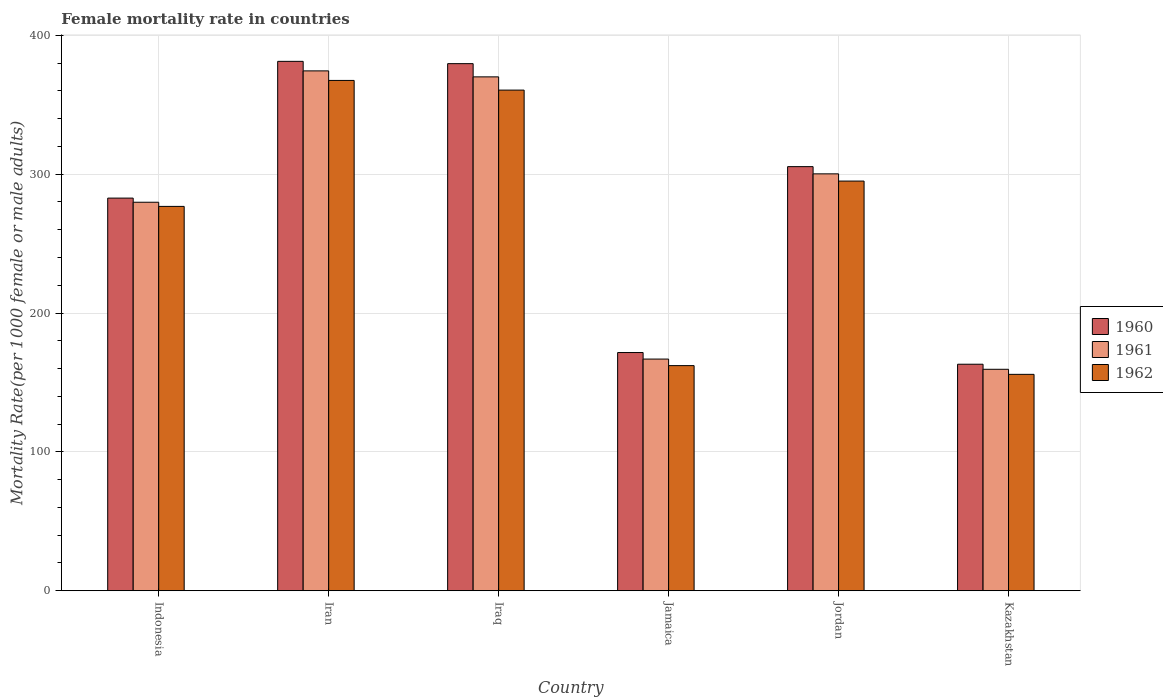How many groups of bars are there?
Ensure brevity in your answer.  6. Are the number of bars per tick equal to the number of legend labels?
Offer a very short reply. Yes. Are the number of bars on each tick of the X-axis equal?
Ensure brevity in your answer.  Yes. What is the label of the 4th group of bars from the left?
Keep it short and to the point. Jamaica. In how many cases, is the number of bars for a given country not equal to the number of legend labels?
Provide a short and direct response. 0. What is the female mortality rate in 1960 in Kazakhstan?
Provide a short and direct response. 163.12. Across all countries, what is the maximum female mortality rate in 1962?
Your answer should be compact. 367.5. Across all countries, what is the minimum female mortality rate in 1960?
Keep it short and to the point. 163.12. In which country was the female mortality rate in 1960 maximum?
Your response must be concise. Iran. In which country was the female mortality rate in 1961 minimum?
Make the answer very short. Kazakhstan. What is the total female mortality rate in 1960 in the graph?
Keep it short and to the point. 1683.64. What is the difference between the female mortality rate in 1960 in Indonesia and that in Kazakhstan?
Your answer should be very brief. 119.63. What is the difference between the female mortality rate in 1961 in Jordan and the female mortality rate in 1962 in Kazakhstan?
Give a very brief answer. 144.4. What is the average female mortality rate in 1961 per country?
Your answer should be compact. 275.12. What is the difference between the female mortality rate of/in 1962 and female mortality rate of/in 1960 in Indonesia?
Your response must be concise. -5.98. In how many countries, is the female mortality rate in 1962 greater than 200?
Your answer should be compact. 4. What is the ratio of the female mortality rate in 1961 in Iran to that in Iraq?
Keep it short and to the point. 1.01. Is the difference between the female mortality rate in 1962 in Indonesia and Jamaica greater than the difference between the female mortality rate in 1960 in Indonesia and Jamaica?
Provide a succinct answer. Yes. What is the difference between the highest and the second highest female mortality rate in 1962?
Offer a terse response. 65.51. What is the difference between the highest and the lowest female mortality rate in 1961?
Make the answer very short. 214.9. Is the sum of the female mortality rate in 1962 in Indonesia and Jordan greater than the maximum female mortality rate in 1960 across all countries?
Your answer should be very brief. Yes. What does the 1st bar from the right in Kazakhstan represents?
Your answer should be very brief. 1962. Are the values on the major ticks of Y-axis written in scientific E-notation?
Offer a terse response. No. Does the graph contain grids?
Your response must be concise. Yes. Where does the legend appear in the graph?
Your response must be concise. Center right. What is the title of the graph?
Offer a very short reply. Female mortality rate in countries. Does "1972" appear as one of the legend labels in the graph?
Your answer should be very brief. No. What is the label or title of the X-axis?
Give a very brief answer. Country. What is the label or title of the Y-axis?
Provide a short and direct response. Mortality Rate(per 1000 female or male adults). What is the Mortality Rate(per 1000 female or male adults) in 1960 in Indonesia?
Provide a short and direct response. 282.75. What is the Mortality Rate(per 1000 female or male adults) in 1961 in Indonesia?
Ensure brevity in your answer.  279.76. What is the Mortality Rate(per 1000 female or male adults) of 1962 in Indonesia?
Offer a terse response. 276.78. What is the Mortality Rate(per 1000 female or male adults) in 1960 in Iran?
Ensure brevity in your answer.  381.24. What is the Mortality Rate(per 1000 female or male adults) of 1961 in Iran?
Your response must be concise. 374.37. What is the Mortality Rate(per 1000 female or male adults) of 1962 in Iran?
Provide a succinct answer. 367.5. What is the Mortality Rate(per 1000 female or male adults) of 1960 in Iraq?
Give a very brief answer. 379.58. What is the Mortality Rate(per 1000 female or male adults) in 1961 in Iraq?
Your response must be concise. 370.06. What is the Mortality Rate(per 1000 female or male adults) in 1962 in Iraq?
Make the answer very short. 360.53. What is the Mortality Rate(per 1000 female or male adults) of 1960 in Jamaica?
Your response must be concise. 171.53. What is the Mortality Rate(per 1000 female or male adults) of 1961 in Jamaica?
Provide a short and direct response. 166.82. What is the Mortality Rate(per 1000 female or male adults) of 1962 in Jamaica?
Keep it short and to the point. 162.11. What is the Mortality Rate(per 1000 female or male adults) of 1960 in Jordan?
Ensure brevity in your answer.  305.41. What is the Mortality Rate(per 1000 female or male adults) in 1961 in Jordan?
Your response must be concise. 300.22. What is the Mortality Rate(per 1000 female or male adults) of 1962 in Jordan?
Your response must be concise. 295.02. What is the Mortality Rate(per 1000 female or male adults) in 1960 in Kazakhstan?
Your response must be concise. 163.12. What is the Mortality Rate(per 1000 female or male adults) in 1961 in Kazakhstan?
Offer a terse response. 159.47. What is the Mortality Rate(per 1000 female or male adults) in 1962 in Kazakhstan?
Offer a terse response. 155.82. Across all countries, what is the maximum Mortality Rate(per 1000 female or male adults) in 1960?
Ensure brevity in your answer.  381.24. Across all countries, what is the maximum Mortality Rate(per 1000 female or male adults) in 1961?
Keep it short and to the point. 374.37. Across all countries, what is the maximum Mortality Rate(per 1000 female or male adults) of 1962?
Make the answer very short. 367.5. Across all countries, what is the minimum Mortality Rate(per 1000 female or male adults) in 1960?
Offer a terse response. 163.12. Across all countries, what is the minimum Mortality Rate(per 1000 female or male adults) of 1961?
Offer a terse response. 159.47. Across all countries, what is the minimum Mortality Rate(per 1000 female or male adults) in 1962?
Provide a short and direct response. 155.82. What is the total Mortality Rate(per 1000 female or male adults) of 1960 in the graph?
Provide a short and direct response. 1683.64. What is the total Mortality Rate(per 1000 female or male adults) of 1961 in the graph?
Your answer should be compact. 1650.7. What is the total Mortality Rate(per 1000 female or male adults) of 1962 in the graph?
Offer a terse response. 1617.76. What is the difference between the Mortality Rate(per 1000 female or male adults) in 1960 in Indonesia and that in Iran?
Keep it short and to the point. -98.49. What is the difference between the Mortality Rate(per 1000 female or male adults) of 1961 in Indonesia and that in Iran?
Your answer should be very brief. -94.6. What is the difference between the Mortality Rate(per 1000 female or male adults) in 1962 in Indonesia and that in Iran?
Provide a succinct answer. -90.72. What is the difference between the Mortality Rate(per 1000 female or male adults) in 1960 in Indonesia and that in Iraq?
Your response must be concise. -96.83. What is the difference between the Mortality Rate(per 1000 female or male adults) in 1961 in Indonesia and that in Iraq?
Ensure brevity in your answer.  -90.29. What is the difference between the Mortality Rate(per 1000 female or male adults) in 1962 in Indonesia and that in Iraq?
Offer a terse response. -83.75. What is the difference between the Mortality Rate(per 1000 female or male adults) in 1960 in Indonesia and that in Jamaica?
Keep it short and to the point. 111.22. What is the difference between the Mortality Rate(per 1000 female or male adults) in 1961 in Indonesia and that in Jamaica?
Keep it short and to the point. 112.94. What is the difference between the Mortality Rate(per 1000 female or male adults) of 1962 in Indonesia and that in Jamaica?
Your answer should be compact. 114.66. What is the difference between the Mortality Rate(per 1000 female or male adults) in 1960 in Indonesia and that in Jordan?
Your answer should be very brief. -22.66. What is the difference between the Mortality Rate(per 1000 female or male adults) in 1961 in Indonesia and that in Jordan?
Ensure brevity in your answer.  -20.45. What is the difference between the Mortality Rate(per 1000 female or male adults) of 1962 in Indonesia and that in Jordan?
Provide a succinct answer. -18.24. What is the difference between the Mortality Rate(per 1000 female or male adults) of 1960 in Indonesia and that in Kazakhstan?
Your answer should be very brief. 119.63. What is the difference between the Mortality Rate(per 1000 female or male adults) of 1961 in Indonesia and that in Kazakhstan?
Your answer should be very brief. 120.3. What is the difference between the Mortality Rate(per 1000 female or male adults) of 1962 in Indonesia and that in Kazakhstan?
Your answer should be very brief. 120.96. What is the difference between the Mortality Rate(per 1000 female or male adults) of 1960 in Iran and that in Iraq?
Offer a very short reply. 1.66. What is the difference between the Mortality Rate(per 1000 female or male adults) of 1961 in Iran and that in Iraq?
Your response must be concise. 4.31. What is the difference between the Mortality Rate(per 1000 female or male adults) in 1962 in Iran and that in Iraq?
Provide a succinct answer. 6.97. What is the difference between the Mortality Rate(per 1000 female or male adults) of 1960 in Iran and that in Jamaica?
Your response must be concise. 209.71. What is the difference between the Mortality Rate(per 1000 female or male adults) of 1961 in Iran and that in Jamaica?
Offer a very short reply. 207.55. What is the difference between the Mortality Rate(per 1000 female or male adults) of 1962 in Iran and that in Jamaica?
Offer a terse response. 205.38. What is the difference between the Mortality Rate(per 1000 female or male adults) in 1960 in Iran and that in Jordan?
Your answer should be compact. 75.83. What is the difference between the Mortality Rate(per 1000 female or male adults) of 1961 in Iran and that in Jordan?
Offer a terse response. 74.15. What is the difference between the Mortality Rate(per 1000 female or male adults) in 1962 in Iran and that in Jordan?
Your response must be concise. 72.48. What is the difference between the Mortality Rate(per 1000 female or male adults) of 1960 in Iran and that in Kazakhstan?
Offer a terse response. 218.12. What is the difference between the Mortality Rate(per 1000 female or male adults) in 1961 in Iran and that in Kazakhstan?
Make the answer very short. 214.9. What is the difference between the Mortality Rate(per 1000 female or male adults) in 1962 in Iran and that in Kazakhstan?
Make the answer very short. 211.68. What is the difference between the Mortality Rate(per 1000 female or male adults) in 1960 in Iraq and that in Jamaica?
Your answer should be very brief. 208.05. What is the difference between the Mortality Rate(per 1000 female or male adults) of 1961 in Iraq and that in Jamaica?
Your response must be concise. 203.23. What is the difference between the Mortality Rate(per 1000 female or male adults) in 1962 in Iraq and that in Jamaica?
Your answer should be very brief. 198.42. What is the difference between the Mortality Rate(per 1000 female or male adults) in 1960 in Iraq and that in Jordan?
Provide a succinct answer. 74.17. What is the difference between the Mortality Rate(per 1000 female or male adults) in 1961 in Iraq and that in Jordan?
Provide a succinct answer. 69.84. What is the difference between the Mortality Rate(per 1000 female or male adults) in 1962 in Iraq and that in Jordan?
Give a very brief answer. 65.51. What is the difference between the Mortality Rate(per 1000 female or male adults) in 1960 in Iraq and that in Kazakhstan?
Your response must be concise. 216.46. What is the difference between the Mortality Rate(per 1000 female or male adults) of 1961 in Iraq and that in Kazakhstan?
Your answer should be very brief. 210.59. What is the difference between the Mortality Rate(per 1000 female or male adults) in 1962 in Iraq and that in Kazakhstan?
Make the answer very short. 204.71. What is the difference between the Mortality Rate(per 1000 female or male adults) of 1960 in Jamaica and that in Jordan?
Your answer should be very brief. -133.88. What is the difference between the Mortality Rate(per 1000 female or male adults) of 1961 in Jamaica and that in Jordan?
Provide a short and direct response. -133.39. What is the difference between the Mortality Rate(per 1000 female or male adults) of 1962 in Jamaica and that in Jordan?
Offer a terse response. -132.91. What is the difference between the Mortality Rate(per 1000 female or male adults) of 1960 in Jamaica and that in Kazakhstan?
Keep it short and to the point. 8.41. What is the difference between the Mortality Rate(per 1000 female or male adults) of 1961 in Jamaica and that in Kazakhstan?
Give a very brief answer. 7.35. What is the difference between the Mortality Rate(per 1000 female or male adults) in 1962 in Jamaica and that in Kazakhstan?
Your answer should be very brief. 6.29. What is the difference between the Mortality Rate(per 1000 female or male adults) of 1960 in Jordan and that in Kazakhstan?
Ensure brevity in your answer.  142.29. What is the difference between the Mortality Rate(per 1000 female or male adults) of 1961 in Jordan and that in Kazakhstan?
Offer a very short reply. 140.75. What is the difference between the Mortality Rate(per 1000 female or male adults) in 1962 in Jordan and that in Kazakhstan?
Your answer should be very brief. 139.2. What is the difference between the Mortality Rate(per 1000 female or male adults) of 1960 in Indonesia and the Mortality Rate(per 1000 female or male adults) of 1961 in Iran?
Your answer should be very brief. -91.62. What is the difference between the Mortality Rate(per 1000 female or male adults) of 1960 in Indonesia and the Mortality Rate(per 1000 female or male adults) of 1962 in Iran?
Keep it short and to the point. -84.75. What is the difference between the Mortality Rate(per 1000 female or male adults) of 1961 in Indonesia and the Mortality Rate(per 1000 female or male adults) of 1962 in Iran?
Your answer should be very brief. -87.73. What is the difference between the Mortality Rate(per 1000 female or male adults) in 1960 in Indonesia and the Mortality Rate(per 1000 female or male adults) in 1961 in Iraq?
Offer a very short reply. -87.3. What is the difference between the Mortality Rate(per 1000 female or male adults) in 1960 in Indonesia and the Mortality Rate(per 1000 female or male adults) in 1962 in Iraq?
Your answer should be very brief. -77.78. What is the difference between the Mortality Rate(per 1000 female or male adults) of 1961 in Indonesia and the Mortality Rate(per 1000 female or male adults) of 1962 in Iraq?
Offer a terse response. -80.77. What is the difference between the Mortality Rate(per 1000 female or male adults) in 1960 in Indonesia and the Mortality Rate(per 1000 female or male adults) in 1961 in Jamaica?
Keep it short and to the point. 115.93. What is the difference between the Mortality Rate(per 1000 female or male adults) of 1960 in Indonesia and the Mortality Rate(per 1000 female or male adults) of 1962 in Jamaica?
Your answer should be very brief. 120.64. What is the difference between the Mortality Rate(per 1000 female or male adults) of 1961 in Indonesia and the Mortality Rate(per 1000 female or male adults) of 1962 in Jamaica?
Make the answer very short. 117.65. What is the difference between the Mortality Rate(per 1000 female or male adults) of 1960 in Indonesia and the Mortality Rate(per 1000 female or male adults) of 1961 in Jordan?
Offer a terse response. -17.46. What is the difference between the Mortality Rate(per 1000 female or male adults) of 1960 in Indonesia and the Mortality Rate(per 1000 female or male adults) of 1962 in Jordan?
Make the answer very short. -12.27. What is the difference between the Mortality Rate(per 1000 female or male adults) in 1961 in Indonesia and the Mortality Rate(per 1000 female or male adults) in 1962 in Jordan?
Provide a short and direct response. -15.26. What is the difference between the Mortality Rate(per 1000 female or male adults) in 1960 in Indonesia and the Mortality Rate(per 1000 female or male adults) in 1961 in Kazakhstan?
Make the answer very short. 123.28. What is the difference between the Mortality Rate(per 1000 female or male adults) of 1960 in Indonesia and the Mortality Rate(per 1000 female or male adults) of 1962 in Kazakhstan?
Provide a short and direct response. 126.93. What is the difference between the Mortality Rate(per 1000 female or male adults) in 1961 in Indonesia and the Mortality Rate(per 1000 female or male adults) in 1962 in Kazakhstan?
Offer a very short reply. 123.94. What is the difference between the Mortality Rate(per 1000 female or male adults) in 1960 in Iran and the Mortality Rate(per 1000 female or male adults) in 1961 in Iraq?
Your answer should be compact. 11.19. What is the difference between the Mortality Rate(per 1000 female or male adults) in 1960 in Iran and the Mortality Rate(per 1000 female or male adults) in 1962 in Iraq?
Ensure brevity in your answer.  20.71. What is the difference between the Mortality Rate(per 1000 female or male adults) in 1961 in Iran and the Mortality Rate(per 1000 female or male adults) in 1962 in Iraq?
Provide a succinct answer. 13.84. What is the difference between the Mortality Rate(per 1000 female or male adults) of 1960 in Iran and the Mortality Rate(per 1000 female or male adults) of 1961 in Jamaica?
Offer a very short reply. 214.42. What is the difference between the Mortality Rate(per 1000 female or male adults) in 1960 in Iran and the Mortality Rate(per 1000 female or male adults) in 1962 in Jamaica?
Your answer should be compact. 219.13. What is the difference between the Mortality Rate(per 1000 female or male adults) of 1961 in Iran and the Mortality Rate(per 1000 female or male adults) of 1962 in Jamaica?
Provide a succinct answer. 212.25. What is the difference between the Mortality Rate(per 1000 female or male adults) of 1960 in Iran and the Mortality Rate(per 1000 female or male adults) of 1961 in Jordan?
Provide a succinct answer. 81.03. What is the difference between the Mortality Rate(per 1000 female or male adults) of 1960 in Iran and the Mortality Rate(per 1000 female or male adults) of 1962 in Jordan?
Offer a terse response. 86.22. What is the difference between the Mortality Rate(per 1000 female or male adults) in 1961 in Iran and the Mortality Rate(per 1000 female or male adults) in 1962 in Jordan?
Make the answer very short. 79.35. What is the difference between the Mortality Rate(per 1000 female or male adults) in 1960 in Iran and the Mortality Rate(per 1000 female or male adults) in 1961 in Kazakhstan?
Give a very brief answer. 221.77. What is the difference between the Mortality Rate(per 1000 female or male adults) in 1960 in Iran and the Mortality Rate(per 1000 female or male adults) in 1962 in Kazakhstan?
Make the answer very short. 225.42. What is the difference between the Mortality Rate(per 1000 female or male adults) of 1961 in Iran and the Mortality Rate(per 1000 female or male adults) of 1962 in Kazakhstan?
Your response must be concise. 218.55. What is the difference between the Mortality Rate(per 1000 female or male adults) of 1960 in Iraq and the Mortality Rate(per 1000 female or male adults) of 1961 in Jamaica?
Provide a succinct answer. 212.76. What is the difference between the Mortality Rate(per 1000 female or male adults) in 1960 in Iraq and the Mortality Rate(per 1000 female or male adults) in 1962 in Jamaica?
Offer a terse response. 217.47. What is the difference between the Mortality Rate(per 1000 female or male adults) in 1961 in Iraq and the Mortality Rate(per 1000 female or male adults) in 1962 in Jamaica?
Offer a terse response. 207.94. What is the difference between the Mortality Rate(per 1000 female or male adults) in 1960 in Iraq and the Mortality Rate(per 1000 female or male adults) in 1961 in Jordan?
Offer a very short reply. 79.37. What is the difference between the Mortality Rate(per 1000 female or male adults) in 1960 in Iraq and the Mortality Rate(per 1000 female or male adults) in 1962 in Jordan?
Provide a succinct answer. 84.56. What is the difference between the Mortality Rate(per 1000 female or male adults) of 1961 in Iraq and the Mortality Rate(per 1000 female or male adults) of 1962 in Jordan?
Offer a very short reply. 75.04. What is the difference between the Mortality Rate(per 1000 female or male adults) of 1960 in Iraq and the Mortality Rate(per 1000 female or male adults) of 1961 in Kazakhstan?
Your answer should be very brief. 220.11. What is the difference between the Mortality Rate(per 1000 female or male adults) of 1960 in Iraq and the Mortality Rate(per 1000 female or male adults) of 1962 in Kazakhstan?
Make the answer very short. 223.76. What is the difference between the Mortality Rate(per 1000 female or male adults) in 1961 in Iraq and the Mortality Rate(per 1000 female or male adults) in 1962 in Kazakhstan?
Keep it short and to the point. 214.24. What is the difference between the Mortality Rate(per 1000 female or male adults) in 1960 in Jamaica and the Mortality Rate(per 1000 female or male adults) in 1961 in Jordan?
Give a very brief answer. -128.68. What is the difference between the Mortality Rate(per 1000 female or male adults) in 1960 in Jamaica and the Mortality Rate(per 1000 female or male adults) in 1962 in Jordan?
Your answer should be compact. -123.49. What is the difference between the Mortality Rate(per 1000 female or male adults) of 1961 in Jamaica and the Mortality Rate(per 1000 female or male adults) of 1962 in Jordan?
Offer a very short reply. -128.2. What is the difference between the Mortality Rate(per 1000 female or male adults) in 1960 in Jamaica and the Mortality Rate(per 1000 female or male adults) in 1961 in Kazakhstan?
Offer a very short reply. 12.06. What is the difference between the Mortality Rate(per 1000 female or male adults) of 1960 in Jamaica and the Mortality Rate(per 1000 female or male adults) of 1962 in Kazakhstan?
Your answer should be very brief. 15.71. What is the difference between the Mortality Rate(per 1000 female or male adults) in 1961 in Jamaica and the Mortality Rate(per 1000 female or male adults) in 1962 in Kazakhstan?
Provide a succinct answer. 11. What is the difference between the Mortality Rate(per 1000 female or male adults) of 1960 in Jordan and the Mortality Rate(per 1000 female or male adults) of 1961 in Kazakhstan?
Your answer should be very brief. 145.94. What is the difference between the Mortality Rate(per 1000 female or male adults) in 1960 in Jordan and the Mortality Rate(per 1000 female or male adults) in 1962 in Kazakhstan?
Make the answer very short. 149.59. What is the difference between the Mortality Rate(per 1000 female or male adults) of 1961 in Jordan and the Mortality Rate(per 1000 female or male adults) of 1962 in Kazakhstan?
Provide a short and direct response. 144.4. What is the average Mortality Rate(per 1000 female or male adults) in 1960 per country?
Offer a terse response. 280.61. What is the average Mortality Rate(per 1000 female or male adults) of 1961 per country?
Offer a very short reply. 275.12. What is the average Mortality Rate(per 1000 female or male adults) in 1962 per country?
Give a very brief answer. 269.63. What is the difference between the Mortality Rate(per 1000 female or male adults) in 1960 and Mortality Rate(per 1000 female or male adults) in 1961 in Indonesia?
Make the answer very short. 2.99. What is the difference between the Mortality Rate(per 1000 female or male adults) in 1960 and Mortality Rate(per 1000 female or male adults) in 1962 in Indonesia?
Your answer should be very brief. 5.98. What is the difference between the Mortality Rate(per 1000 female or male adults) of 1961 and Mortality Rate(per 1000 female or male adults) of 1962 in Indonesia?
Provide a succinct answer. 2.99. What is the difference between the Mortality Rate(per 1000 female or male adults) of 1960 and Mortality Rate(per 1000 female or male adults) of 1961 in Iran?
Ensure brevity in your answer.  6.87. What is the difference between the Mortality Rate(per 1000 female or male adults) of 1960 and Mortality Rate(per 1000 female or male adults) of 1962 in Iran?
Provide a short and direct response. 13.74. What is the difference between the Mortality Rate(per 1000 female or male adults) of 1961 and Mortality Rate(per 1000 female or male adults) of 1962 in Iran?
Give a very brief answer. 6.87. What is the difference between the Mortality Rate(per 1000 female or male adults) of 1960 and Mortality Rate(per 1000 female or male adults) of 1961 in Iraq?
Ensure brevity in your answer.  9.53. What is the difference between the Mortality Rate(per 1000 female or male adults) of 1960 and Mortality Rate(per 1000 female or male adults) of 1962 in Iraq?
Make the answer very short. 19.05. What is the difference between the Mortality Rate(per 1000 female or male adults) in 1961 and Mortality Rate(per 1000 female or male adults) in 1962 in Iraq?
Your response must be concise. 9.53. What is the difference between the Mortality Rate(per 1000 female or male adults) of 1960 and Mortality Rate(per 1000 female or male adults) of 1961 in Jamaica?
Give a very brief answer. 4.71. What is the difference between the Mortality Rate(per 1000 female or male adults) in 1960 and Mortality Rate(per 1000 female or male adults) in 1962 in Jamaica?
Keep it short and to the point. 9.42. What is the difference between the Mortality Rate(per 1000 female or male adults) of 1961 and Mortality Rate(per 1000 female or male adults) of 1962 in Jamaica?
Your answer should be compact. 4.71. What is the difference between the Mortality Rate(per 1000 female or male adults) in 1960 and Mortality Rate(per 1000 female or male adults) in 1961 in Jordan?
Offer a terse response. 5.2. What is the difference between the Mortality Rate(per 1000 female or male adults) in 1960 and Mortality Rate(per 1000 female or male adults) in 1962 in Jordan?
Offer a very short reply. 10.39. What is the difference between the Mortality Rate(per 1000 female or male adults) of 1961 and Mortality Rate(per 1000 female or male adults) of 1962 in Jordan?
Offer a very short reply. 5.2. What is the difference between the Mortality Rate(per 1000 female or male adults) in 1960 and Mortality Rate(per 1000 female or male adults) in 1961 in Kazakhstan?
Your answer should be compact. 3.65. What is the difference between the Mortality Rate(per 1000 female or male adults) in 1960 and Mortality Rate(per 1000 female or male adults) in 1962 in Kazakhstan?
Make the answer very short. 7.3. What is the difference between the Mortality Rate(per 1000 female or male adults) of 1961 and Mortality Rate(per 1000 female or male adults) of 1962 in Kazakhstan?
Keep it short and to the point. 3.65. What is the ratio of the Mortality Rate(per 1000 female or male adults) of 1960 in Indonesia to that in Iran?
Provide a short and direct response. 0.74. What is the ratio of the Mortality Rate(per 1000 female or male adults) of 1961 in Indonesia to that in Iran?
Ensure brevity in your answer.  0.75. What is the ratio of the Mortality Rate(per 1000 female or male adults) of 1962 in Indonesia to that in Iran?
Ensure brevity in your answer.  0.75. What is the ratio of the Mortality Rate(per 1000 female or male adults) in 1960 in Indonesia to that in Iraq?
Offer a very short reply. 0.74. What is the ratio of the Mortality Rate(per 1000 female or male adults) in 1961 in Indonesia to that in Iraq?
Provide a short and direct response. 0.76. What is the ratio of the Mortality Rate(per 1000 female or male adults) in 1962 in Indonesia to that in Iraq?
Offer a very short reply. 0.77. What is the ratio of the Mortality Rate(per 1000 female or male adults) in 1960 in Indonesia to that in Jamaica?
Offer a very short reply. 1.65. What is the ratio of the Mortality Rate(per 1000 female or male adults) in 1961 in Indonesia to that in Jamaica?
Keep it short and to the point. 1.68. What is the ratio of the Mortality Rate(per 1000 female or male adults) of 1962 in Indonesia to that in Jamaica?
Ensure brevity in your answer.  1.71. What is the ratio of the Mortality Rate(per 1000 female or male adults) of 1960 in Indonesia to that in Jordan?
Your response must be concise. 0.93. What is the ratio of the Mortality Rate(per 1000 female or male adults) in 1961 in Indonesia to that in Jordan?
Make the answer very short. 0.93. What is the ratio of the Mortality Rate(per 1000 female or male adults) of 1962 in Indonesia to that in Jordan?
Your answer should be compact. 0.94. What is the ratio of the Mortality Rate(per 1000 female or male adults) in 1960 in Indonesia to that in Kazakhstan?
Provide a short and direct response. 1.73. What is the ratio of the Mortality Rate(per 1000 female or male adults) of 1961 in Indonesia to that in Kazakhstan?
Provide a succinct answer. 1.75. What is the ratio of the Mortality Rate(per 1000 female or male adults) in 1962 in Indonesia to that in Kazakhstan?
Keep it short and to the point. 1.78. What is the ratio of the Mortality Rate(per 1000 female or male adults) of 1960 in Iran to that in Iraq?
Your answer should be very brief. 1. What is the ratio of the Mortality Rate(per 1000 female or male adults) of 1961 in Iran to that in Iraq?
Give a very brief answer. 1.01. What is the ratio of the Mortality Rate(per 1000 female or male adults) of 1962 in Iran to that in Iraq?
Offer a terse response. 1.02. What is the ratio of the Mortality Rate(per 1000 female or male adults) of 1960 in Iran to that in Jamaica?
Make the answer very short. 2.22. What is the ratio of the Mortality Rate(per 1000 female or male adults) of 1961 in Iran to that in Jamaica?
Give a very brief answer. 2.24. What is the ratio of the Mortality Rate(per 1000 female or male adults) of 1962 in Iran to that in Jamaica?
Make the answer very short. 2.27. What is the ratio of the Mortality Rate(per 1000 female or male adults) of 1960 in Iran to that in Jordan?
Give a very brief answer. 1.25. What is the ratio of the Mortality Rate(per 1000 female or male adults) of 1961 in Iran to that in Jordan?
Provide a short and direct response. 1.25. What is the ratio of the Mortality Rate(per 1000 female or male adults) in 1962 in Iran to that in Jordan?
Offer a very short reply. 1.25. What is the ratio of the Mortality Rate(per 1000 female or male adults) in 1960 in Iran to that in Kazakhstan?
Offer a terse response. 2.34. What is the ratio of the Mortality Rate(per 1000 female or male adults) in 1961 in Iran to that in Kazakhstan?
Offer a very short reply. 2.35. What is the ratio of the Mortality Rate(per 1000 female or male adults) in 1962 in Iran to that in Kazakhstan?
Give a very brief answer. 2.36. What is the ratio of the Mortality Rate(per 1000 female or male adults) of 1960 in Iraq to that in Jamaica?
Make the answer very short. 2.21. What is the ratio of the Mortality Rate(per 1000 female or male adults) in 1961 in Iraq to that in Jamaica?
Ensure brevity in your answer.  2.22. What is the ratio of the Mortality Rate(per 1000 female or male adults) of 1962 in Iraq to that in Jamaica?
Your answer should be very brief. 2.22. What is the ratio of the Mortality Rate(per 1000 female or male adults) in 1960 in Iraq to that in Jordan?
Keep it short and to the point. 1.24. What is the ratio of the Mortality Rate(per 1000 female or male adults) in 1961 in Iraq to that in Jordan?
Ensure brevity in your answer.  1.23. What is the ratio of the Mortality Rate(per 1000 female or male adults) in 1962 in Iraq to that in Jordan?
Offer a terse response. 1.22. What is the ratio of the Mortality Rate(per 1000 female or male adults) in 1960 in Iraq to that in Kazakhstan?
Your answer should be compact. 2.33. What is the ratio of the Mortality Rate(per 1000 female or male adults) of 1961 in Iraq to that in Kazakhstan?
Your answer should be very brief. 2.32. What is the ratio of the Mortality Rate(per 1000 female or male adults) in 1962 in Iraq to that in Kazakhstan?
Provide a succinct answer. 2.31. What is the ratio of the Mortality Rate(per 1000 female or male adults) of 1960 in Jamaica to that in Jordan?
Your answer should be very brief. 0.56. What is the ratio of the Mortality Rate(per 1000 female or male adults) in 1961 in Jamaica to that in Jordan?
Provide a short and direct response. 0.56. What is the ratio of the Mortality Rate(per 1000 female or male adults) of 1962 in Jamaica to that in Jordan?
Provide a succinct answer. 0.55. What is the ratio of the Mortality Rate(per 1000 female or male adults) of 1960 in Jamaica to that in Kazakhstan?
Your answer should be very brief. 1.05. What is the ratio of the Mortality Rate(per 1000 female or male adults) of 1961 in Jamaica to that in Kazakhstan?
Ensure brevity in your answer.  1.05. What is the ratio of the Mortality Rate(per 1000 female or male adults) of 1962 in Jamaica to that in Kazakhstan?
Your answer should be compact. 1.04. What is the ratio of the Mortality Rate(per 1000 female or male adults) of 1960 in Jordan to that in Kazakhstan?
Provide a short and direct response. 1.87. What is the ratio of the Mortality Rate(per 1000 female or male adults) of 1961 in Jordan to that in Kazakhstan?
Your answer should be very brief. 1.88. What is the ratio of the Mortality Rate(per 1000 female or male adults) in 1962 in Jordan to that in Kazakhstan?
Provide a short and direct response. 1.89. What is the difference between the highest and the second highest Mortality Rate(per 1000 female or male adults) of 1960?
Offer a terse response. 1.66. What is the difference between the highest and the second highest Mortality Rate(per 1000 female or male adults) of 1961?
Ensure brevity in your answer.  4.31. What is the difference between the highest and the second highest Mortality Rate(per 1000 female or male adults) of 1962?
Keep it short and to the point. 6.97. What is the difference between the highest and the lowest Mortality Rate(per 1000 female or male adults) of 1960?
Provide a succinct answer. 218.12. What is the difference between the highest and the lowest Mortality Rate(per 1000 female or male adults) of 1961?
Offer a very short reply. 214.9. What is the difference between the highest and the lowest Mortality Rate(per 1000 female or male adults) in 1962?
Give a very brief answer. 211.68. 